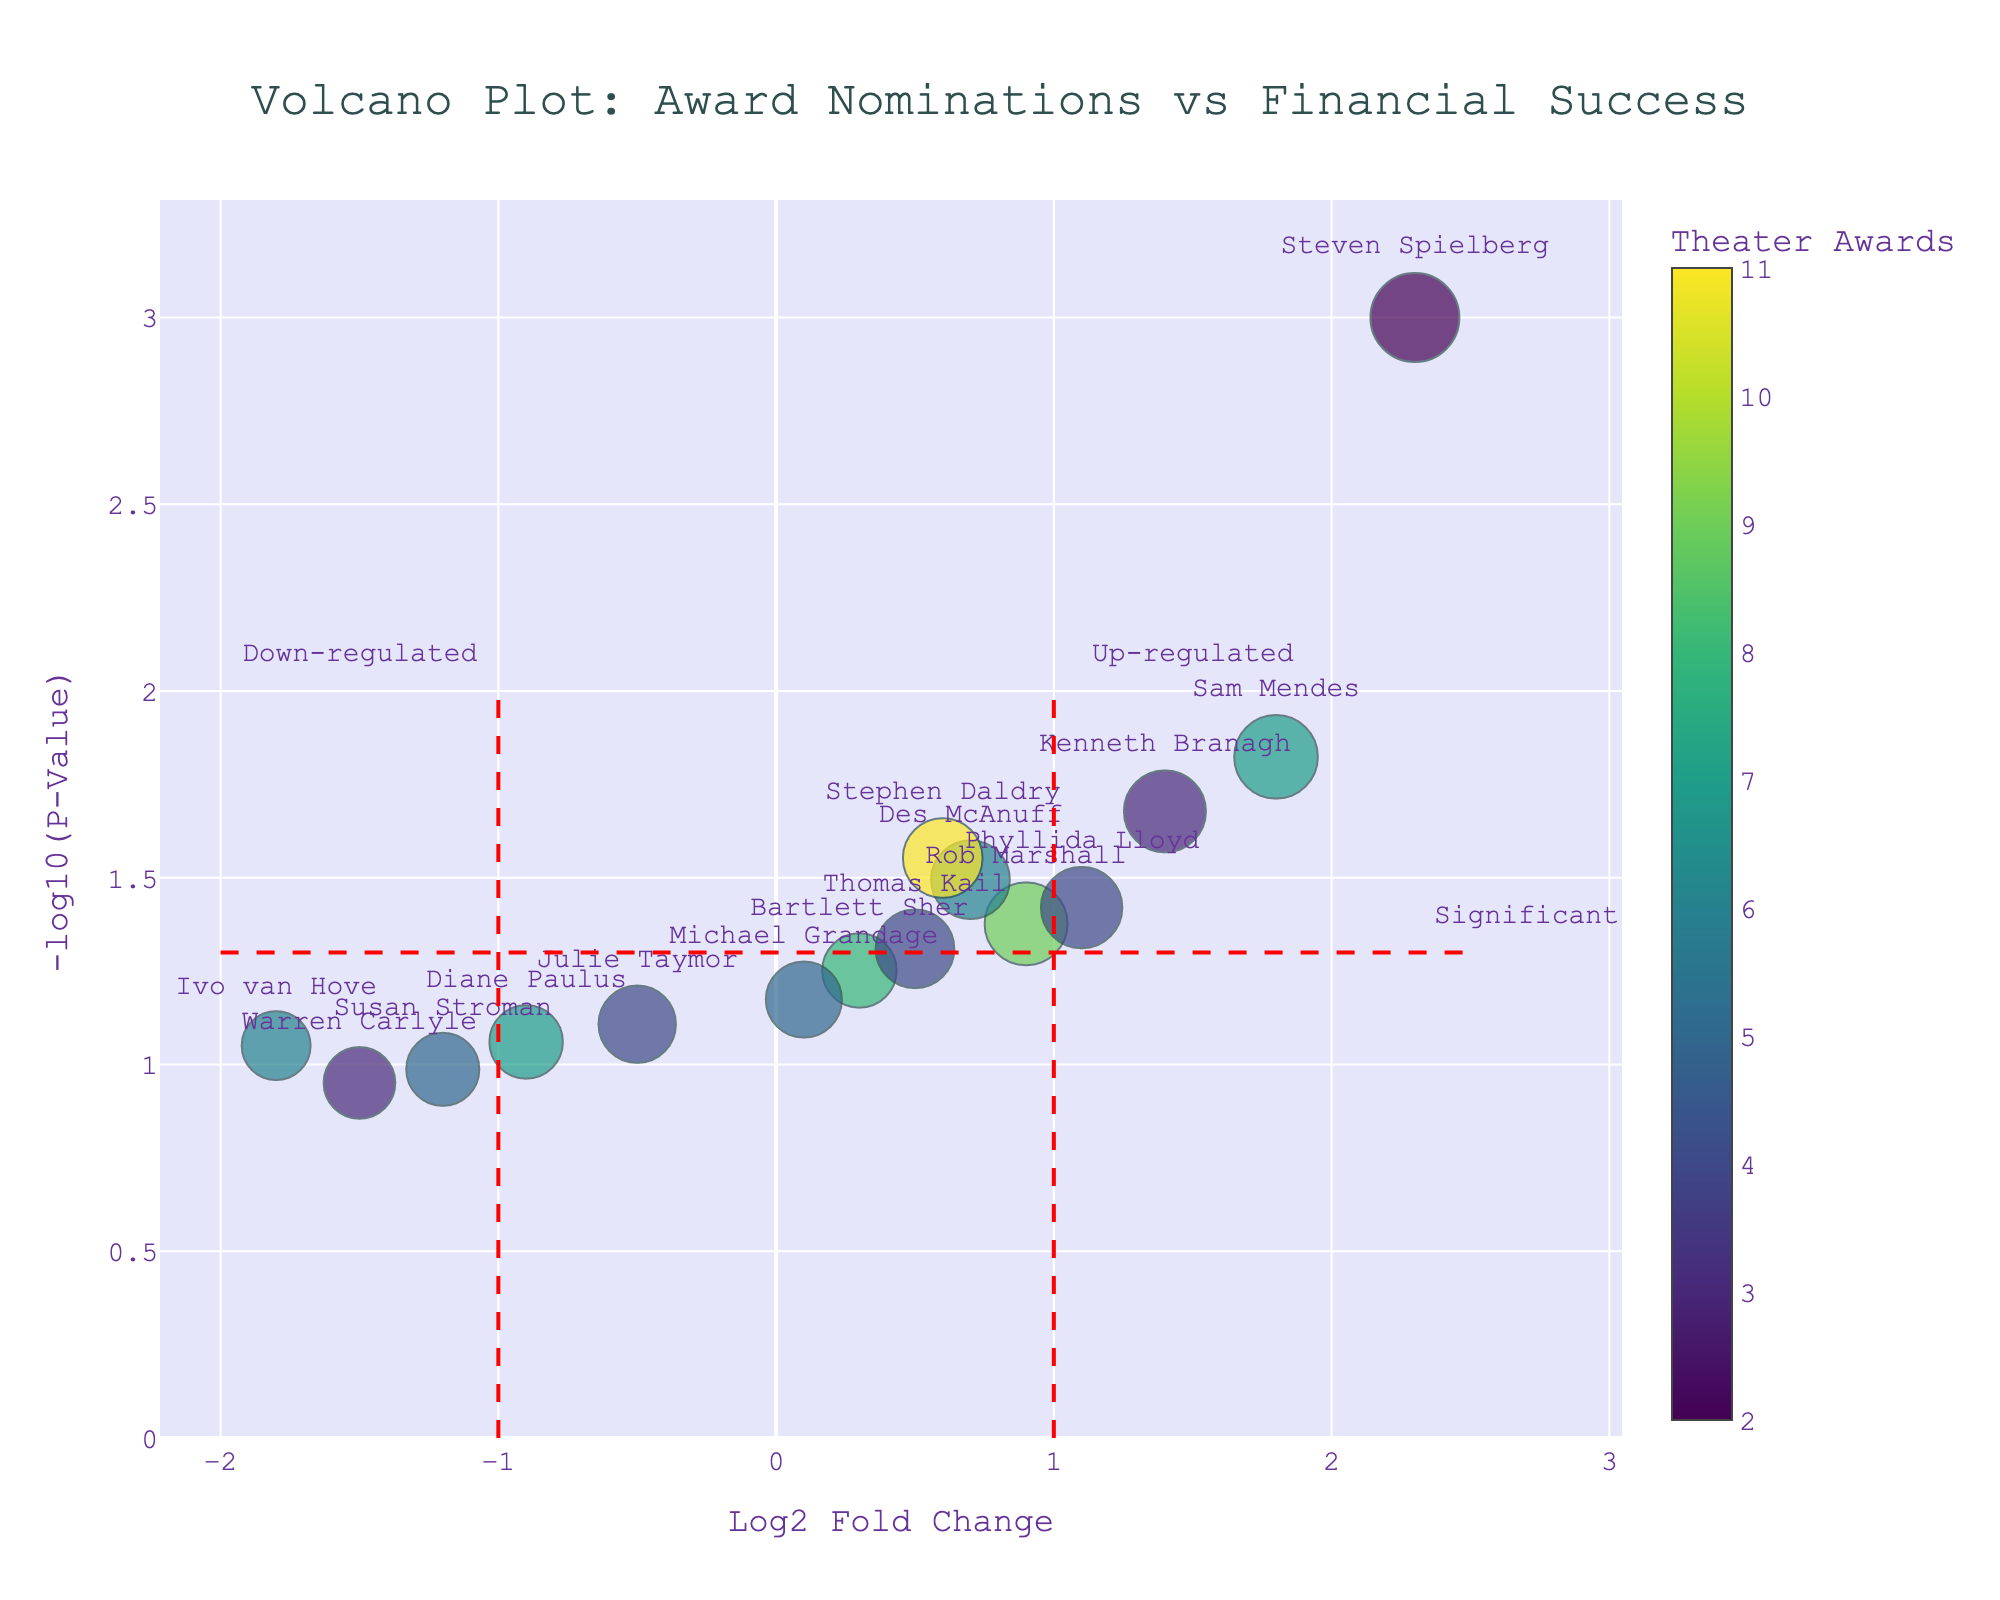What's the title of the plot? The title of the plot is displayed at the top center of the figure in a large font.
Answer: Volcano Plot: Award Nominations vs Financial Success What does the x-axis represent? The x-axis label is provided below the horizontal axis of the plot.
Answer: Log2 Fold Change Which director has the highest value of -log10(P-Value)? The data point with the maximum vertical position (highest -log10(P-Value)) has hover text showing the director's name.
Answer: Steven Spielberg How many directors have a Log2 Fold Change greater than 1? Count the data points that are to the right of the vertical line at Log2 Fold Change = 1.
Answer: 4 Which director has the highest film gross and what is it? The hover text for each data point includes the film gross. Identify the one with the highest value.
Answer: Steven Spielberg, $4,500,000,000 Compare the number of theater awards and film awards for Rob Marshall. Who has more? Refer to the hover text for Rob Marshall and compare the values for theater and film awards.
Answer: Theater Awards: 9, Film Awards: 6; Theater has more Identify the directors who are labeled as up-regulated. The area marked “Up-regulated” is beyond the vertical line at Log2 Fold Change = 1. Look for directors in this region.
Answer: Steven Spielberg, Kenneth Branagh How many directors fall into the significant category? The significant category is above the horizontal red line at -log10(P-Value) = 1.3. Count data points in this area.
Answer: 8 Which director with a film gross under $100,000,000 has the lowest Log2 Fold Change, and what is their P-Value? Review the hover text for points with film gross under $100,000,000 and identify the one with the lowest Log2 Fold Change.
Answer: Susan Stroman, 0.103 What trend can be observed in terms of Log2 Fold Change for directors with high numbers of theater awards? Look at the colors, which indicate the number of theater awards, and their positions on the x-axis. A general pattern emerges.
Answer: Directors with higher theater awards tend to have a diverse range of Log2 Fold Changes 